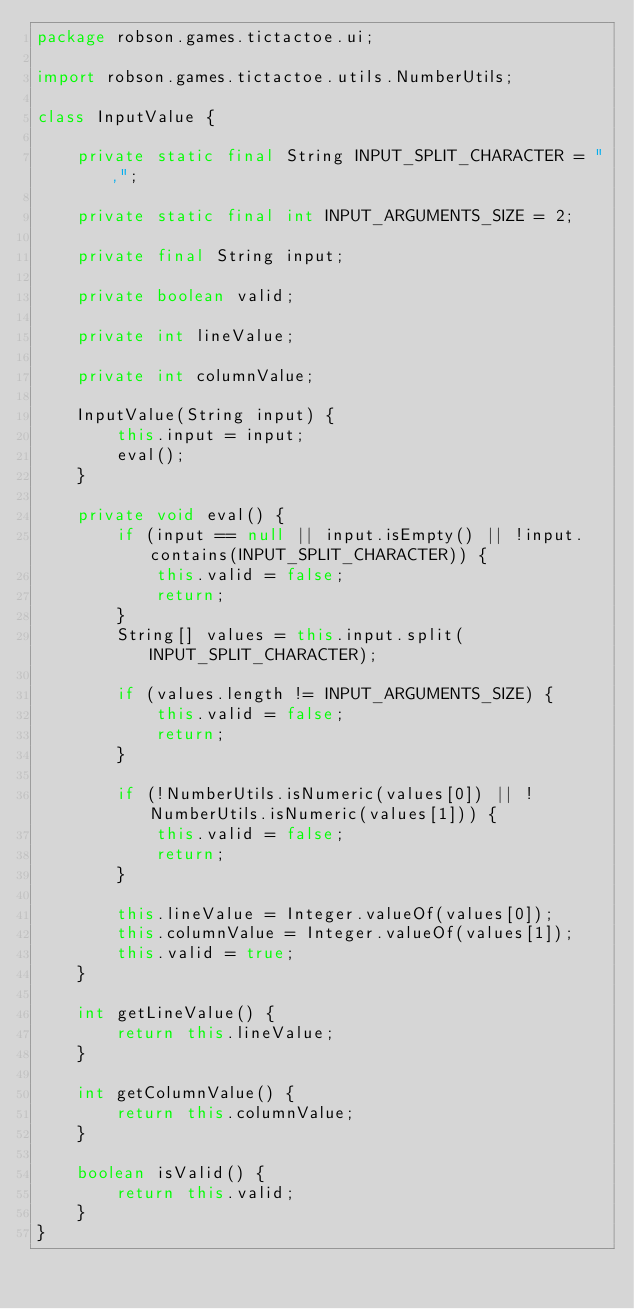<code> <loc_0><loc_0><loc_500><loc_500><_Java_>package robson.games.tictactoe.ui;

import robson.games.tictactoe.utils.NumberUtils;

class InputValue {

    private static final String INPUT_SPLIT_CHARACTER = ",";

    private static final int INPUT_ARGUMENTS_SIZE = 2;

    private final String input;

    private boolean valid;

    private int lineValue;

    private int columnValue;

    InputValue(String input) {
        this.input = input;
        eval();
    }

    private void eval() {
        if (input == null || input.isEmpty() || !input.contains(INPUT_SPLIT_CHARACTER)) {
            this.valid = false;
            return;
        }
        String[] values = this.input.split(INPUT_SPLIT_CHARACTER);

        if (values.length != INPUT_ARGUMENTS_SIZE) {
            this.valid = false;
            return;
        }

        if (!NumberUtils.isNumeric(values[0]) || !NumberUtils.isNumeric(values[1])) {
            this.valid = false;
            return;
        }

        this.lineValue = Integer.valueOf(values[0]);
        this.columnValue = Integer.valueOf(values[1]);
        this.valid = true;
    }

    int getLineValue() {
        return this.lineValue;
    }

    int getColumnValue() {
        return this.columnValue;
    }

    boolean isValid() {
        return this.valid;
    }
}
</code> 